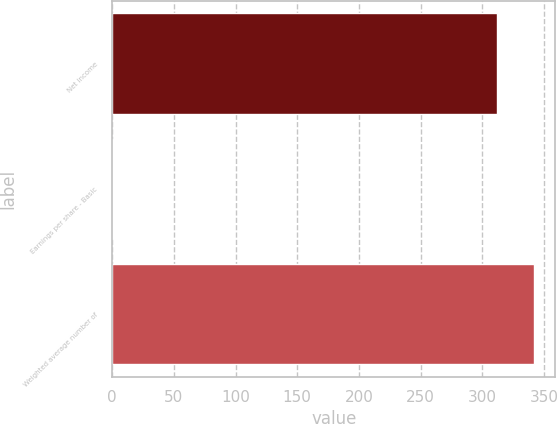Convert chart to OTSL. <chart><loc_0><loc_0><loc_500><loc_500><bar_chart><fcel>Net income<fcel>Earnings per share - Basic<fcel>Weighted average number of<nl><fcel>311.91<fcel>0.87<fcel>342.22<nl></chart> 